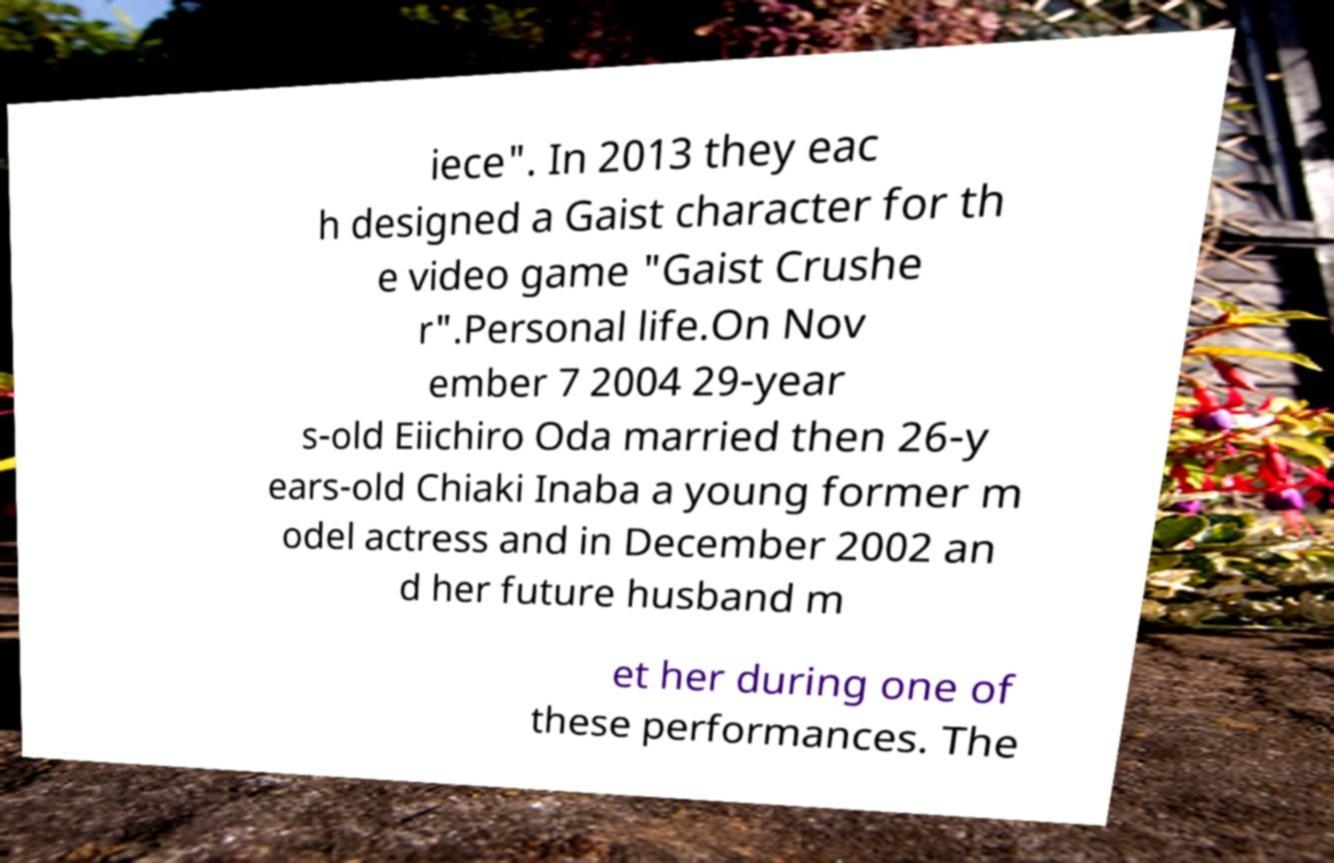Could you extract and type out the text from this image? iece". In 2013 they eac h designed a Gaist character for th e video game "Gaist Crushe r".Personal life.On Nov ember 7 2004 29-year s-old Eiichiro Oda married then 26-y ears-old Chiaki Inaba a young former m odel actress and in December 2002 an d her future husband m et her during one of these performances. The 